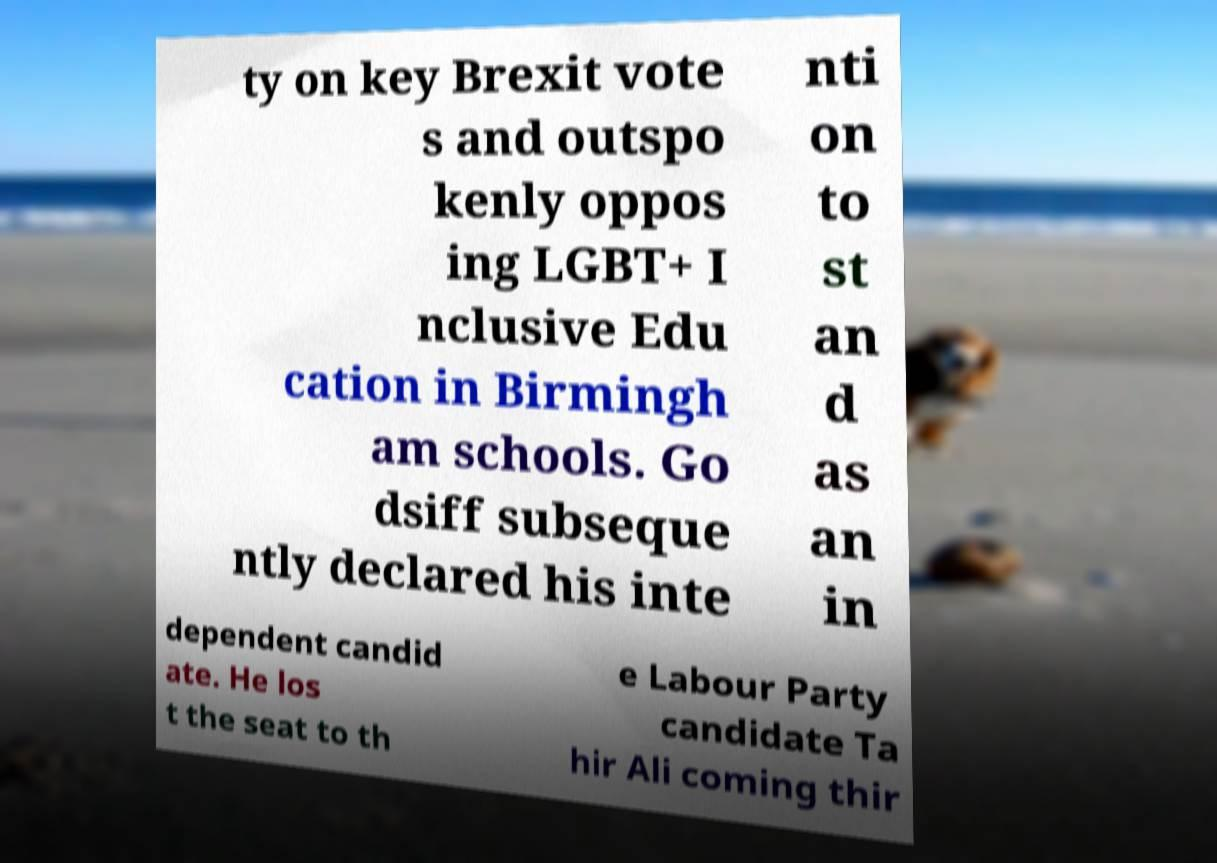Please read and relay the text visible in this image. What does it say? ty on key Brexit vote s and outspo kenly oppos ing LGBT+ I nclusive Edu cation in Birmingh am schools. Go dsiff subseque ntly declared his inte nti on to st an d as an in dependent candid ate. He los t the seat to th e Labour Party candidate Ta hir Ali coming thir 